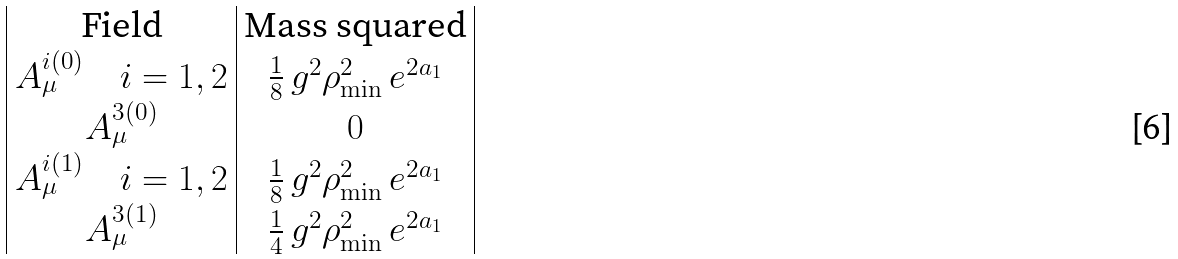<formula> <loc_0><loc_0><loc_500><loc_500>\begin{array} { | c | c | } \text {Field} & \text {Mass squared} \\ A ^ { i ( 0 ) } _ { \mu } \quad i = 1 , 2 & \frac { 1 } { 8 } \, g ^ { 2 } \rho ^ { 2 } _ { \min } \, e ^ { 2 a _ { 1 } } \\ A ^ { 3 ( 0 ) } _ { \mu } & 0 \\ A ^ { i ( 1 ) } _ { \mu } \quad i = 1 , 2 & \frac { 1 } { 8 } \, g ^ { 2 } \rho ^ { 2 } _ { \min } \, e ^ { 2 a _ { 1 } } \\ A ^ { 3 ( 1 ) } _ { \mu } & \frac { 1 } { 4 } \, g ^ { 2 } \rho ^ { 2 } _ { \min } \, e ^ { 2 a _ { 1 } } \\ \end{array}</formula> 